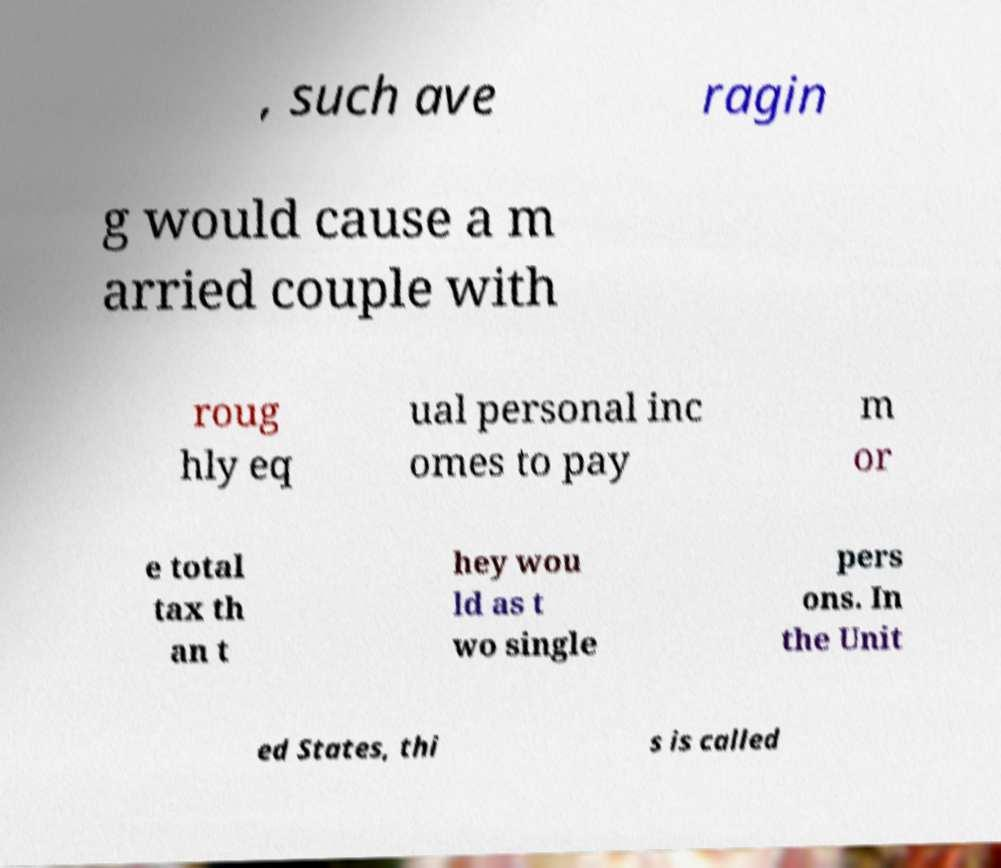What messages or text are displayed in this image? I need them in a readable, typed format. , such ave ragin g would cause a m arried couple with roug hly eq ual personal inc omes to pay m or e total tax th an t hey wou ld as t wo single pers ons. In the Unit ed States, thi s is called 